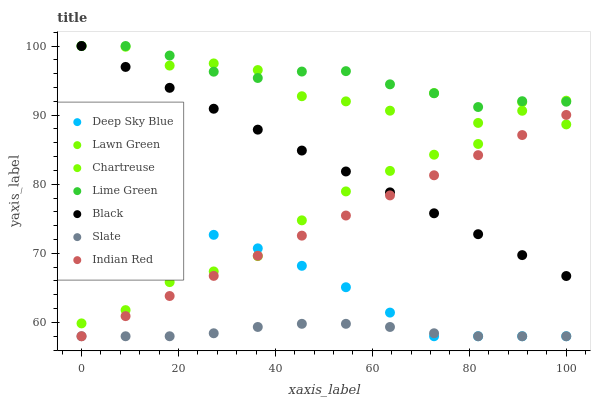Does Slate have the minimum area under the curve?
Answer yes or no. Yes. Does Lime Green have the maximum area under the curve?
Answer yes or no. Yes. Does Indian Red have the minimum area under the curve?
Answer yes or no. No. Does Indian Red have the maximum area under the curve?
Answer yes or no. No. Is Black the smoothest?
Answer yes or no. Yes. Is Lawn Green the roughest?
Answer yes or no. Yes. Is Indian Red the smoothest?
Answer yes or no. No. Is Indian Red the roughest?
Answer yes or no. No. Does Indian Red have the lowest value?
Answer yes or no. Yes. Does Chartreuse have the lowest value?
Answer yes or no. No. Does Lime Green have the highest value?
Answer yes or no. Yes. Does Indian Red have the highest value?
Answer yes or no. No. Is Slate less than Black?
Answer yes or no. Yes. Is Lawn Green greater than Slate?
Answer yes or no. Yes. Does Chartreuse intersect Black?
Answer yes or no. Yes. Is Chartreuse less than Black?
Answer yes or no. No. Is Chartreuse greater than Black?
Answer yes or no. No. Does Slate intersect Black?
Answer yes or no. No. 